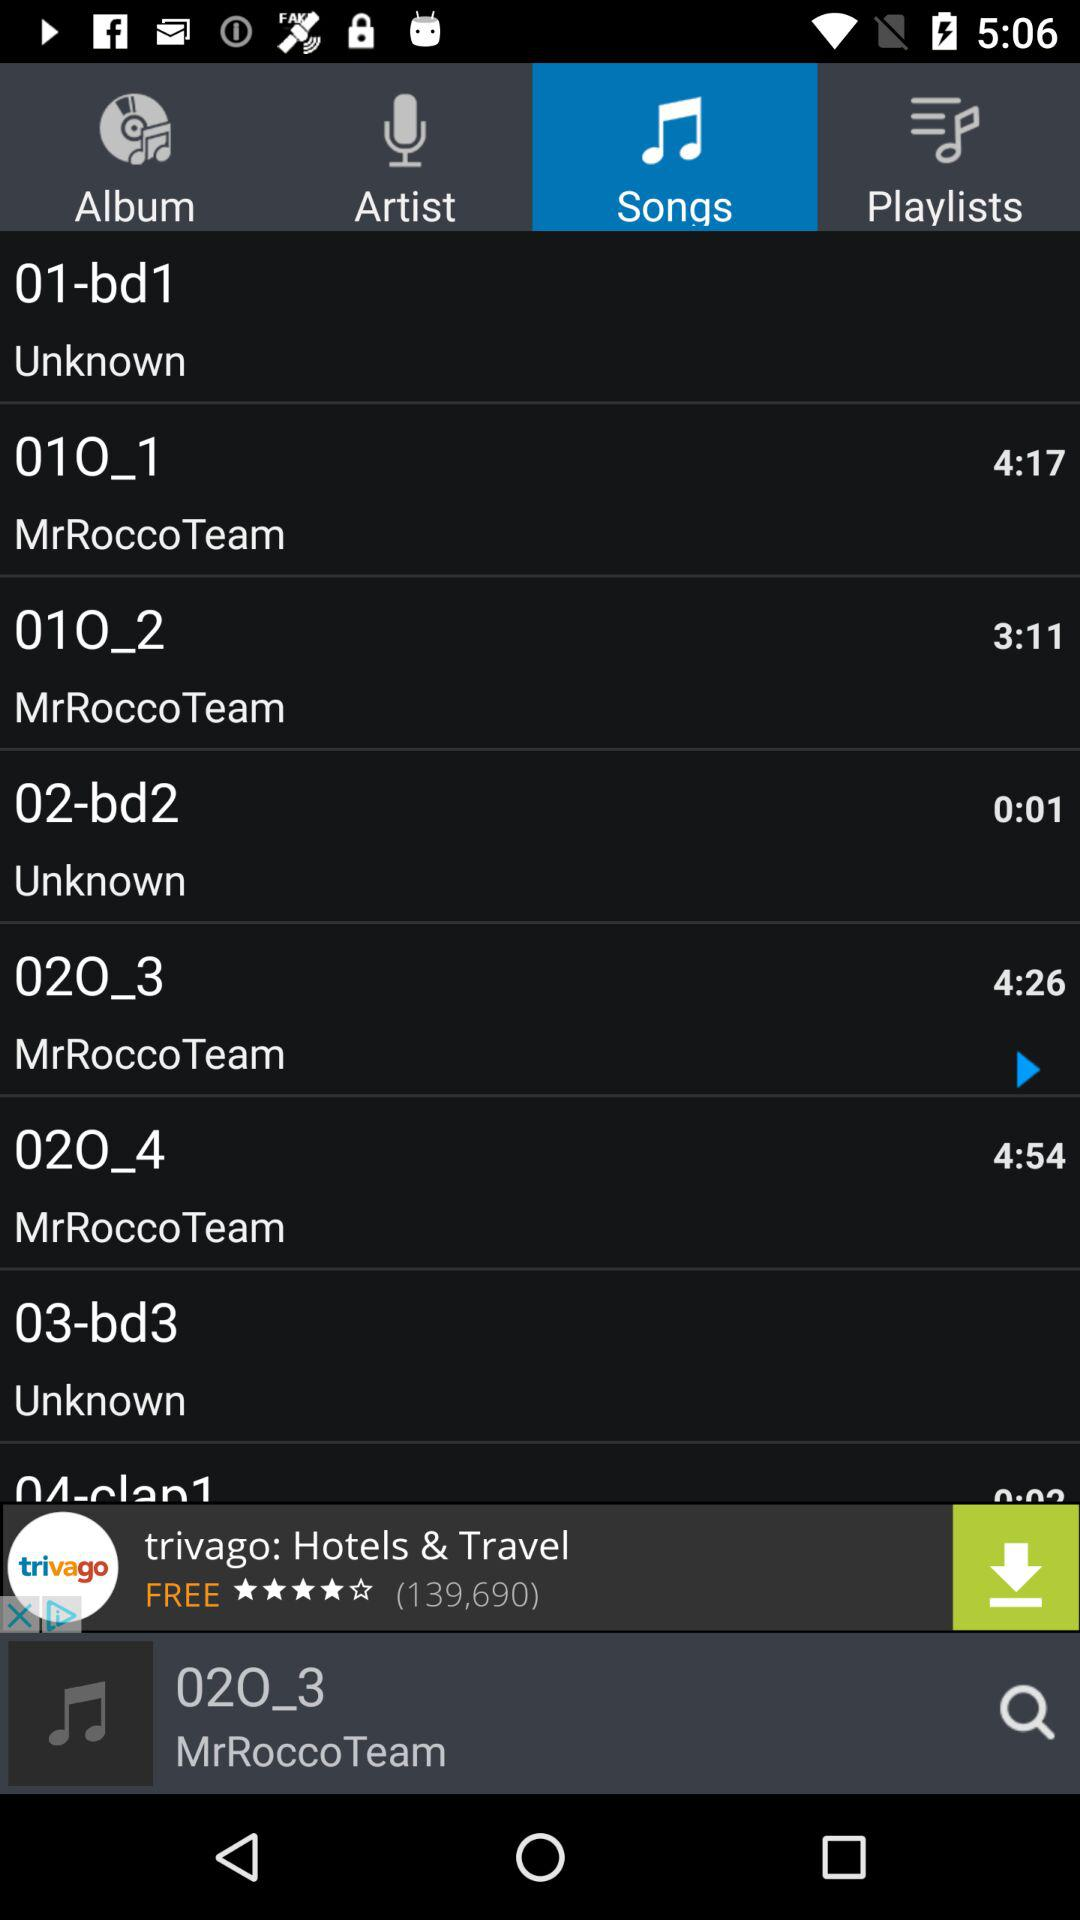What is the duration of "02O_3" song? The duration of "02O_3" song is 4 minutes and 26 seconds. 